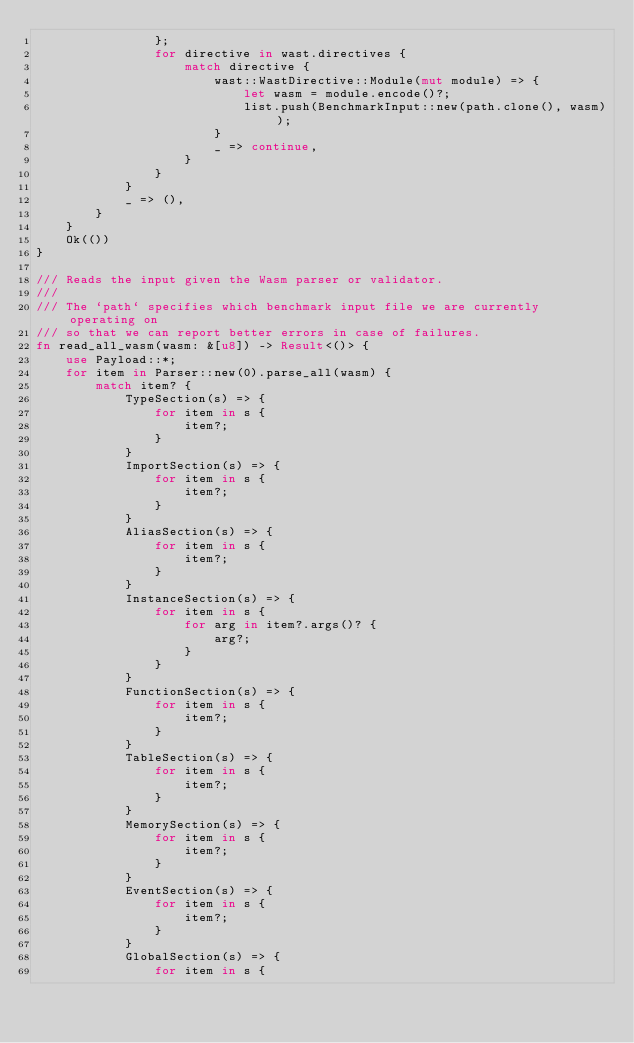Convert code to text. <code><loc_0><loc_0><loc_500><loc_500><_Rust_>                };
                for directive in wast.directives {
                    match directive {
                        wast::WastDirective::Module(mut module) => {
                            let wasm = module.encode()?;
                            list.push(BenchmarkInput::new(path.clone(), wasm));
                        }
                        _ => continue,
                    }
                }
            }
            _ => (),
        }
    }
    Ok(())
}

/// Reads the input given the Wasm parser or validator.
///
/// The `path` specifies which benchmark input file we are currently operating on
/// so that we can report better errors in case of failures.
fn read_all_wasm(wasm: &[u8]) -> Result<()> {
    use Payload::*;
    for item in Parser::new(0).parse_all(wasm) {
        match item? {
            TypeSection(s) => {
                for item in s {
                    item?;
                }
            }
            ImportSection(s) => {
                for item in s {
                    item?;
                }
            }
            AliasSection(s) => {
                for item in s {
                    item?;
                }
            }
            InstanceSection(s) => {
                for item in s {
                    for arg in item?.args()? {
                        arg?;
                    }
                }
            }
            FunctionSection(s) => {
                for item in s {
                    item?;
                }
            }
            TableSection(s) => {
                for item in s {
                    item?;
                }
            }
            MemorySection(s) => {
                for item in s {
                    item?;
                }
            }
            EventSection(s) => {
                for item in s {
                    item?;
                }
            }
            GlobalSection(s) => {
                for item in s {</code> 